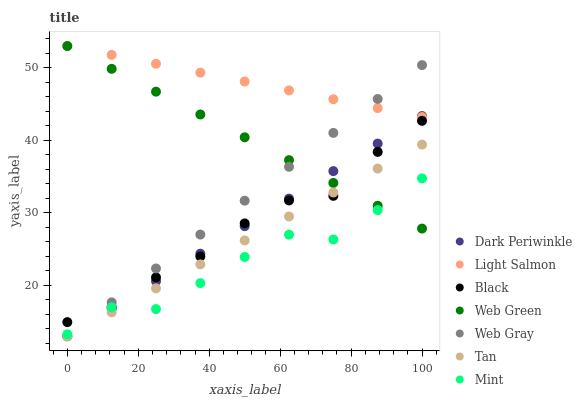Does Mint have the minimum area under the curve?
Answer yes or no. Yes. Does Light Salmon have the maximum area under the curve?
Answer yes or no. Yes. Does Web Gray have the minimum area under the curve?
Answer yes or no. No. Does Web Gray have the maximum area under the curve?
Answer yes or no. No. Is Light Salmon the smoothest?
Answer yes or no. Yes. Is Mint the roughest?
Answer yes or no. Yes. Is Web Gray the smoothest?
Answer yes or no. No. Is Web Gray the roughest?
Answer yes or no. No. Does Web Gray have the lowest value?
Answer yes or no. Yes. Does Web Green have the lowest value?
Answer yes or no. No. Does Web Green have the highest value?
Answer yes or no. Yes. Does Web Gray have the highest value?
Answer yes or no. No. Is Black less than Light Salmon?
Answer yes or no. Yes. Is Light Salmon greater than Tan?
Answer yes or no. Yes. Does Black intersect Web Green?
Answer yes or no. Yes. Is Black less than Web Green?
Answer yes or no. No. Is Black greater than Web Green?
Answer yes or no. No. Does Black intersect Light Salmon?
Answer yes or no. No. 